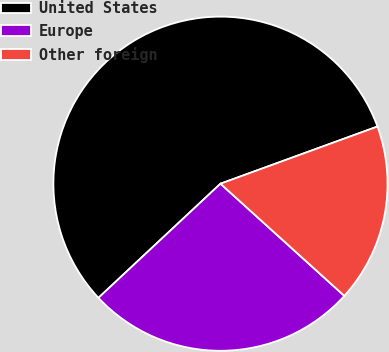Convert chart. <chart><loc_0><loc_0><loc_500><loc_500><pie_chart><fcel>United States<fcel>Europe<fcel>Other foreign<nl><fcel>56.41%<fcel>26.32%<fcel>17.27%<nl></chart> 